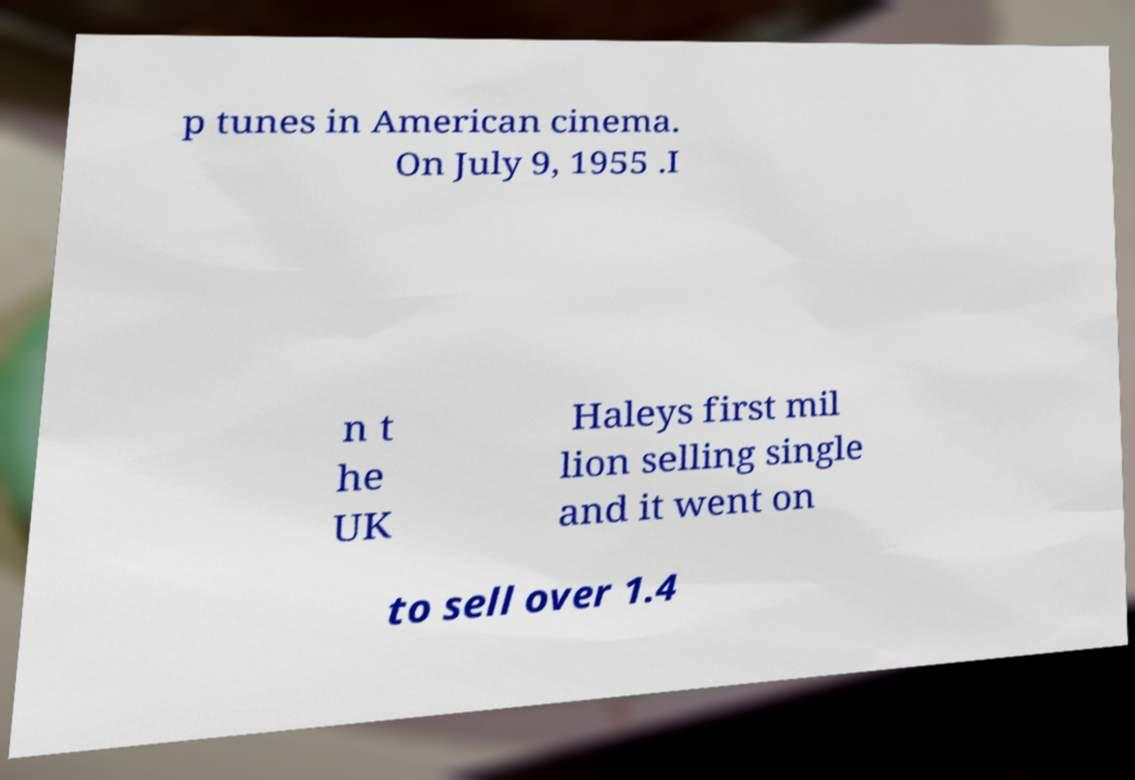Could you extract and type out the text from this image? p tunes in American cinema. On July 9, 1955 .I n t he UK Haleys first mil lion selling single and it went on to sell over 1.4 